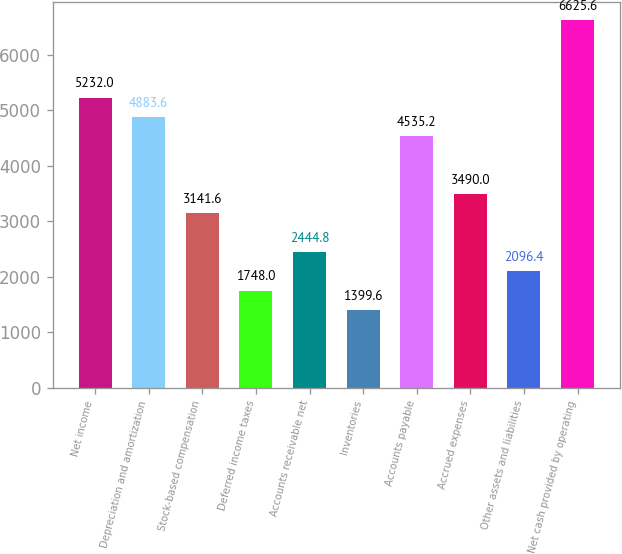Convert chart. <chart><loc_0><loc_0><loc_500><loc_500><bar_chart><fcel>Net income<fcel>Depreciation and amortization<fcel>Stock-based compensation<fcel>Deferred income taxes<fcel>Accounts receivable net<fcel>Inventories<fcel>Accounts payable<fcel>Accrued expenses<fcel>Other assets and liabilities<fcel>Net cash provided by operating<nl><fcel>5232<fcel>4883.6<fcel>3141.6<fcel>1748<fcel>2444.8<fcel>1399.6<fcel>4535.2<fcel>3490<fcel>2096.4<fcel>6625.6<nl></chart> 